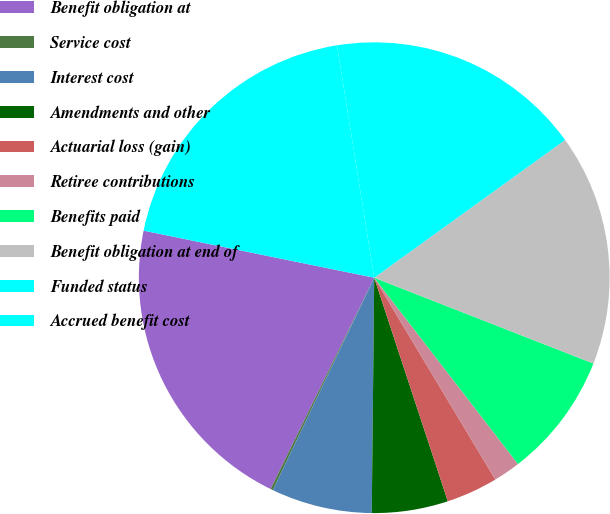<chart> <loc_0><loc_0><loc_500><loc_500><pie_chart><fcel>Benefit obligation at<fcel>Service cost<fcel>Interest cost<fcel>Amendments and other<fcel>Actuarial loss (gain)<fcel>Retiree contributions<fcel>Benefits paid<fcel>Benefit obligation at end of<fcel>Funded status<fcel>Accrued benefit cost<nl><fcel>20.95%<fcel>0.17%<fcel>6.92%<fcel>5.23%<fcel>3.54%<fcel>1.86%<fcel>8.6%<fcel>15.89%<fcel>17.58%<fcel>19.27%<nl></chart> 